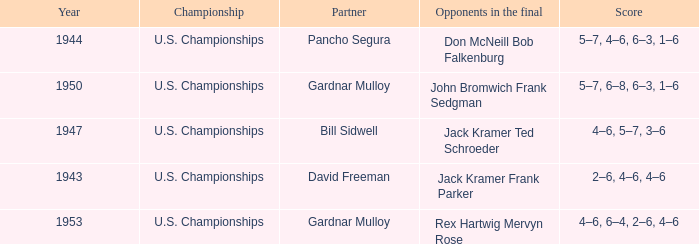Which Championship has a Score of 2–6, 4–6, 4–6? U.S. Championships. 